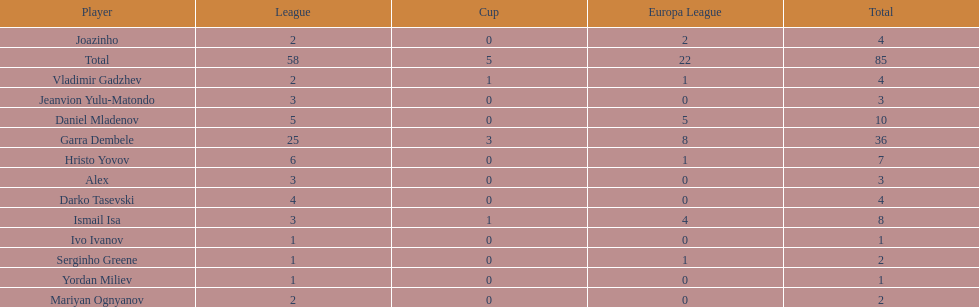Could you help me parse every detail presented in this table? {'header': ['Player', 'League', 'Cup', 'Europa League', 'Total'], 'rows': [['Joazinho', '2', '0', '2', '4'], ['Total', '58', '5', '22', '85'], ['Vladimir Gadzhev', '2', '1', '1', '4'], ['Jeanvion Yulu-Matondo', '3', '0', '0', '3'], ['Daniel Mladenov', '5', '0', '5', '10'], ['Garra Dembele', '25', '3', '8', '36'], ['Hristo Yovov', '6', '0', '1', '7'], ['Alex', '3', '0', '0', '3'], ['Darko Tasevski', '4', '0', '0', '4'], ['Ismail Isa', '3', '1', '4', '8'], ['Ivo Ivanov', '1', '0', '0', '1'], ['Serginho Greene', '1', '0', '1', '2'], ['Yordan Miliev', '1', '0', '0', '1'], ['Mariyan Ognyanov', '2', '0', '0', '2']]} How many players had a total of 4? 3. 